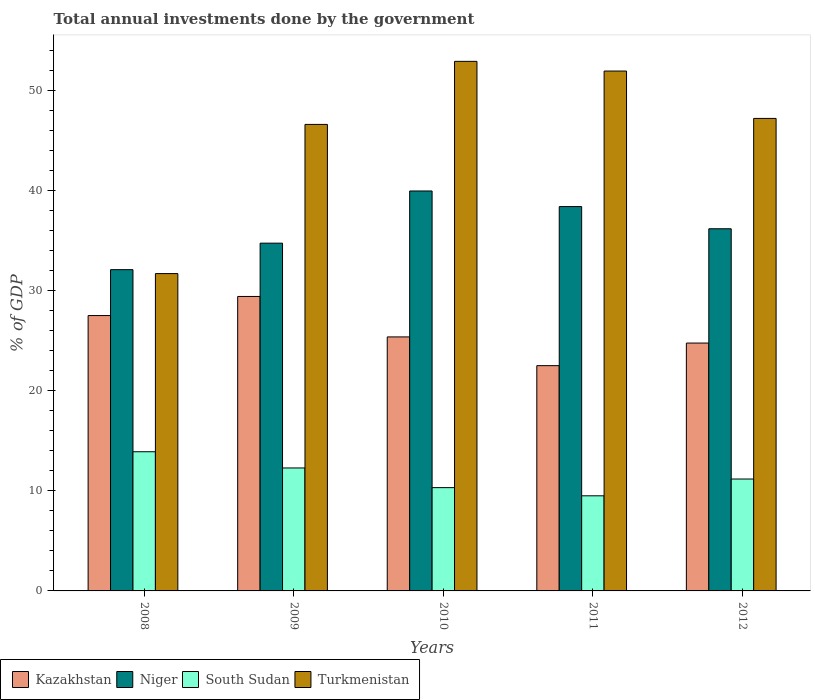How many different coloured bars are there?
Ensure brevity in your answer.  4. How many groups of bars are there?
Give a very brief answer. 5. Are the number of bars on each tick of the X-axis equal?
Offer a terse response. Yes. What is the label of the 3rd group of bars from the left?
Your answer should be compact. 2010. In how many cases, is the number of bars for a given year not equal to the number of legend labels?
Offer a terse response. 0. What is the total annual investments done by the government in Kazakhstan in 2010?
Your answer should be very brief. 25.37. Across all years, what is the maximum total annual investments done by the government in Turkmenistan?
Your answer should be compact. 52.9. Across all years, what is the minimum total annual investments done by the government in Niger?
Make the answer very short. 32.09. In which year was the total annual investments done by the government in Niger maximum?
Your answer should be very brief. 2010. What is the total total annual investments done by the government in Niger in the graph?
Your response must be concise. 181.35. What is the difference between the total annual investments done by the government in Niger in 2011 and that in 2012?
Offer a very short reply. 2.22. What is the difference between the total annual investments done by the government in South Sudan in 2008 and the total annual investments done by the government in Kazakhstan in 2009?
Keep it short and to the point. -15.51. What is the average total annual investments done by the government in Niger per year?
Your response must be concise. 36.27. In the year 2011, what is the difference between the total annual investments done by the government in Niger and total annual investments done by the government in Kazakhstan?
Your answer should be very brief. 15.89. What is the ratio of the total annual investments done by the government in Niger in 2008 to that in 2010?
Your answer should be compact. 0.8. Is the difference between the total annual investments done by the government in Niger in 2008 and 2010 greater than the difference between the total annual investments done by the government in Kazakhstan in 2008 and 2010?
Give a very brief answer. No. What is the difference between the highest and the second highest total annual investments done by the government in Turkmenistan?
Provide a succinct answer. 0.97. What is the difference between the highest and the lowest total annual investments done by the government in Turkmenistan?
Provide a short and direct response. 21.2. In how many years, is the total annual investments done by the government in Niger greater than the average total annual investments done by the government in Niger taken over all years?
Provide a succinct answer. 2. Is it the case that in every year, the sum of the total annual investments done by the government in South Sudan and total annual investments done by the government in Niger is greater than the sum of total annual investments done by the government in Kazakhstan and total annual investments done by the government in Turkmenistan?
Keep it short and to the point. No. What does the 3rd bar from the left in 2012 represents?
Your answer should be very brief. South Sudan. What does the 1st bar from the right in 2008 represents?
Your answer should be compact. Turkmenistan. Are all the bars in the graph horizontal?
Provide a short and direct response. No. How many years are there in the graph?
Keep it short and to the point. 5. Does the graph contain any zero values?
Provide a short and direct response. No. Does the graph contain grids?
Give a very brief answer. No. How many legend labels are there?
Your response must be concise. 4. How are the legend labels stacked?
Your answer should be compact. Horizontal. What is the title of the graph?
Provide a short and direct response. Total annual investments done by the government. Does "Mongolia" appear as one of the legend labels in the graph?
Your answer should be compact. No. What is the label or title of the Y-axis?
Keep it short and to the point. % of GDP. What is the % of GDP of Kazakhstan in 2008?
Offer a very short reply. 27.51. What is the % of GDP of Niger in 2008?
Your answer should be very brief. 32.09. What is the % of GDP in South Sudan in 2008?
Your answer should be very brief. 13.9. What is the % of GDP of Turkmenistan in 2008?
Provide a succinct answer. 31.7. What is the % of GDP of Kazakhstan in 2009?
Offer a terse response. 29.41. What is the % of GDP in Niger in 2009?
Your answer should be very brief. 34.74. What is the % of GDP of South Sudan in 2009?
Ensure brevity in your answer.  12.28. What is the % of GDP in Turkmenistan in 2009?
Keep it short and to the point. 46.6. What is the % of GDP of Kazakhstan in 2010?
Your answer should be compact. 25.37. What is the % of GDP of Niger in 2010?
Provide a succinct answer. 39.95. What is the % of GDP in South Sudan in 2010?
Provide a short and direct response. 10.32. What is the % of GDP of Turkmenistan in 2010?
Offer a terse response. 52.9. What is the % of GDP of Kazakhstan in 2011?
Give a very brief answer. 22.5. What is the % of GDP in Niger in 2011?
Provide a succinct answer. 38.39. What is the % of GDP of South Sudan in 2011?
Your response must be concise. 9.5. What is the % of GDP of Turkmenistan in 2011?
Provide a succinct answer. 51.93. What is the % of GDP of Kazakhstan in 2012?
Offer a terse response. 24.76. What is the % of GDP in Niger in 2012?
Your response must be concise. 36.18. What is the % of GDP of South Sudan in 2012?
Provide a short and direct response. 11.18. What is the % of GDP of Turkmenistan in 2012?
Provide a succinct answer. 47.2. Across all years, what is the maximum % of GDP in Kazakhstan?
Make the answer very short. 29.41. Across all years, what is the maximum % of GDP in Niger?
Ensure brevity in your answer.  39.95. Across all years, what is the maximum % of GDP of South Sudan?
Offer a very short reply. 13.9. Across all years, what is the maximum % of GDP of Turkmenistan?
Ensure brevity in your answer.  52.9. Across all years, what is the minimum % of GDP of Kazakhstan?
Your answer should be compact. 22.5. Across all years, what is the minimum % of GDP in Niger?
Provide a succinct answer. 32.09. Across all years, what is the minimum % of GDP in South Sudan?
Provide a short and direct response. 9.5. Across all years, what is the minimum % of GDP of Turkmenistan?
Ensure brevity in your answer.  31.7. What is the total % of GDP in Kazakhstan in the graph?
Your answer should be compact. 129.56. What is the total % of GDP in Niger in the graph?
Ensure brevity in your answer.  181.35. What is the total % of GDP in South Sudan in the graph?
Offer a very short reply. 57.18. What is the total % of GDP of Turkmenistan in the graph?
Your response must be concise. 230.33. What is the difference between the % of GDP in Kazakhstan in 2008 and that in 2009?
Keep it short and to the point. -1.91. What is the difference between the % of GDP in Niger in 2008 and that in 2009?
Keep it short and to the point. -2.65. What is the difference between the % of GDP of South Sudan in 2008 and that in 2009?
Provide a succinct answer. 1.62. What is the difference between the % of GDP in Turkmenistan in 2008 and that in 2009?
Your answer should be very brief. -14.9. What is the difference between the % of GDP in Kazakhstan in 2008 and that in 2010?
Give a very brief answer. 2.13. What is the difference between the % of GDP of Niger in 2008 and that in 2010?
Offer a terse response. -7.86. What is the difference between the % of GDP in South Sudan in 2008 and that in 2010?
Provide a succinct answer. 3.58. What is the difference between the % of GDP in Turkmenistan in 2008 and that in 2010?
Keep it short and to the point. -21.2. What is the difference between the % of GDP of Kazakhstan in 2008 and that in 2011?
Give a very brief answer. 5. What is the difference between the % of GDP of Niger in 2008 and that in 2011?
Offer a very short reply. -6.3. What is the difference between the % of GDP in South Sudan in 2008 and that in 2011?
Your response must be concise. 4.4. What is the difference between the % of GDP of Turkmenistan in 2008 and that in 2011?
Ensure brevity in your answer.  -20.23. What is the difference between the % of GDP of Kazakhstan in 2008 and that in 2012?
Your response must be concise. 2.75. What is the difference between the % of GDP of Niger in 2008 and that in 2012?
Ensure brevity in your answer.  -4.09. What is the difference between the % of GDP of South Sudan in 2008 and that in 2012?
Provide a succinct answer. 2.72. What is the difference between the % of GDP of Turkmenistan in 2008 and that in 2012?
Offer a terse response. -15.5. What is the difference between the % of GDP of Kazakhstan in 2009 and that in 2010?
Ensure brevity in your answer.  4.04. What is the difference between the % of GDP of Niger in 2009 and that in 2010?
Provide a succinct answer. -5.21. What is the difference between the % of GDP of South Sudan in 2009 and that in 2010?
Keep it short and to the point. 1.97. What is the difference between the % of GDP in Kazakhstan in 2009 and that in 2011?
Provide a succinct answer. 6.91. What is the difference between the % of GDP in Niger in 2009 and that in 2011?
Your response must be concise. -3.66. What is the difference between the % of GDP in South Sudan in 2009 and that in 2011?
Offer a very short reply. 2.78. What is the difference between the % of GDP in Turkmenistan in 2009 and that in 2011?
Your response must be concise. -5.33. What is the difference between the % of GDP of Kazakhstan in 2009 and that in 2012?
Ensure brevity in your answer.  4.65. What is the difference between the % of GDP of Niger in 2009 and that in 2012?
Provide a succinct answer. -1.44. What is the difference between the % of GDP in South Sudan in 2009 and that in 2012?
Your response must be concise. 1.1. What is the difference between the % of GDP of Turkmenistan in 2009 and that in 2012?
Your response must be concise. -0.6. What is the difference between the % of GDP in Kazakhstan in 2010 and that in 2011?
Your answer should be very brief. 2.87. What is the difference between the % of GDP in Niger in 2010 and that in 2011?
Give a very brief answer. 1.56. What is the difference between the % of GDP of South Sudan in 2010 and that in 2011?
Ensure brevity in your answer.  0.82. What is the difference between the % of GDP of Turkmenistan in 2010 and that in 2011?
Make the answer very short. 0.97. What is the difference between the % of GDP of Kazakhstan in 2010 and that in 2012?
Your response must be concise. 0.61. What is the difference between the % of GDP of Niger in 2010 and that in 2012?
Ensure brevity in your answer.  3.77. What is the difference between the % of GDP in South Sudan in 2010 and that in 2012?
Your response must be concise. -0.86. What is the difference between the % of GDP in Turkmenistan in 2010 and that in 2012?
Keep it short and to the point. 5.7. What is the difference between the % of GDP in Kazakhstan in 2011 and that in 2012?
Ensure brevity in your answer.  -2.26. What is the difference between the % of GDP of Niger in 2011 and that in 2012?
Give a very brief answer. 2.22. What is the difference between the % of GDP in South Sudan in 2011 and that in 2012?
Offer a very short reply. -1.68. What is the difference between the % of GDP of Turkmenistan in 2011 and that in 2012?
Offer a terse response. 4.73. What is the difference between the % of GDP in Kazakhstan in 2008 and the % of GDP in Niger in 2009?
Provide a short and direct response. -7.23. What is the difference between the % of GDP in Kazakhstan in 2008 and the % of GDP in South Sudan in 2009?
Offer a very short reply. 15.22. What is the difference between the % of GDP in Kazakhstan in 2008 and the % of GDP in Turkmenistan in 2009?
Your answer should be very brief. -19.09. What is the difference between the % of GDP in Niger in 2008 and the % of GDP in South Sudan in 2009?
Your response must be concise. 19.81. What is the difference between the % of GDP of Niger in 2008 and the % of GDP of Turkmenistan in 2009?
Give a very brief answer. -14.51. What is the difference between the % of GDP in South Sudan in 2008 and the % of GDP in Turkmenistan in 2009?
Your response must be concise. -32.7. What is the difference between the % of GDP in Kazakhstan in 2008 and the % of GDP in Niger in 2010?
Offer a terse response. -12.45. What is the difference between the % of GDP in Kazakhstan in 2008 and the % of GDP in South Sudan in 2010?
Provide a short and direct response. 17.19. What is the difference between the % of GDP of Kazakhstan in 2008 and the % of GDP of Turkmenistan in 2010?
Your answer should be very brief. -25.39. What is the difference between the % of GDP of Niger in 2008 and the % of GDP of South Sudan in 2010?
Provide a succinct answer. 21.77. What is the difference between the % of GDP in Niger in 2008 and the % of GDP in Turkmenistan in 2010?
Make the answer very short. -20.81. What is the difference between the % of GDP of South Sudan in 2008 and the % of GDP of Turkmenistan in 2010?
Make the answer very short. -39. What is the difference between the % of GDP in Kazakhstan in 2008 and the % of GDP in Niger in 2011?
Offer a very short reply. -10.89. What is the difference between the % of GDP of Kazakhstan in 2008 and the % of GDP of South Sudan in 2011?
Ensure brevity in your answer.  18. What is the difference between the % of GDP in Kazakhstan in 2008 and the % of GDP in Turkmenistan in 2011?
Provide a succinct answer. -24.43. What is the difference between the % of GDP in Niger in 2008 and the % of GDP in South Sudan in 2011?
Ensure brevity in your answer.  22.59. What is the difference between the % of GDP of Niger in 2008 and the % of GDP of Turkmenistan in 2011?
Provide a short and direct response. -19.84. What is the difference between the % of GDP in South Sudan in 2008 and the % of GDP in Turkmenistan in 2011?
Provide a succinct answer. -38.03. What is the difference between the % of GDP of Kazakhstan in 2008 and the % of GDP of Niger in 2012?
Your answer should be compact. -8.67. What is the difference between the % of GDP in Kazakhstan in 2008 and the % of GDP in South Sudan in 2012?
Your answer should be compact. 16.33. What is the difference between the % of GDP in Kazakhstan in 2008 and the % of GDP in Turkmenistan in 2012?
Offer a very short reply. -19.69. What is the difference between the % of GDP of Niger in 2008 and the % of GDP of South Sudan in 2012?
Your answer should be compact. 20.91. What is the difference between the % of GDP in Niger in 2008 and the % of GDP in Turkmenistan in 2012?
Offer a terse response. -15.11. What is the difference between the % of GDP in South Sudan in 2008 and the % of GDP in Turkmenistan in 2012?
Your answer should be very brief. -33.3. What is the difference between the % of GDP in Kazakhstan in 2009 and the % of GDP in Niger in 2010?
Give a very brief answer. -10.54. What is the difference between the % of GDP of Kazakhstan in 2009 and the % of GDP of South Sudan in 2010?
Make the answer very short. 19.1. What is the difference between the % of GDP in Kazakhstan in 2009 and the % of GDP in Turkmenistan in 2010?
Make the answer very short. -23.49. What is the difference between the % of GDP of Niger in 2009 and the % of GDP of South Sudan in 2010?
Keep it short and to the point. 24.42. What is the difference between the % of GDP in Niger in 2009 and the % of GDP in Turkmenistan in 2010?
Your answer should be very brief. -18.16. What is the difference between the % of GDP in South Sudan in 2009 and the % of GDP in Turkmenistan in 2010?
Give a very brief answer. -40.62. What is the difference between the % of GDP of Kazakhstan in 2009 and the % of GDP of Niger in 2011?
Provide a short and direct response. -8.98. What is the difference between the % of GDP in Kazakhstan in 2009 and the % of GDP in South Sudan in 2011?
Provide a short and direct response. 19.91. What is the difference between the % of GDP of Kazakhstan in 2009 and the % of GDP of Turkmenistan in 2011?
Ensure brevity in your answer.  -22.52. What is the difference between the % of GDP in Niger in 2009 and the % of GDP in South Sudan in 2011?
Keep it short and to the point. 25.24. What is the difference between the % of GDP in Niger in 2009 and the % of GDP in Turkmenistan in 2011?
Make the answer very short. -17.19. What is the difference between the % of GDP in South Sudan in 2009 and the % of GDP in Turkmenistan in 2011?
Provide a short and direct response. -39.65. What is the difference between the % of GDP in Kazakhstan in 2009 and the % of GDP in Niger in 2012?
Ensure brevity in your answer.  -6.76. What is the difference between the % of GDP in Kazakhstan in 2009 and the % of GDP in South Sudan in 2012?
Provide a succinct answer. 18.24. What is the difference between the % of GDP of Kazakhstan in 2009 and the % of GDP of Turkmenistan in 2012?
Keep it short and to the point. -17.79. What is the difference between the % of GDP in Niger in 2009 and the % of GDP in South Sudan in 2012?
Offer a terse response. 23.56. What is the difference between the % of GDP of Niger in 2009 and the % of GDP of Turkmenistan in 2012?
Ensure brevity in your answer.  -12.46. What is the difference between the % of GDP in South Sudan in 2009 and the % of GDP in Turkmenistan in 2012?
Give a very brief answer. -34.92. What is the difference between the % of GDP in Kazakhstan in 2010 and the % of GDP in Niger in 2011?
Provide a short and direct response. -13.02. What is the difference between the % of GDP in Kazakhstan in 2010 and the % of GDP in South Sudan in 2011?
Provide a succinct answer. 15.87. What is the difference between the % of GDP in Kazakhstan in 2010 and the % of GDP in Turkmenistan in 2011?
Provide a short and direct response. -26.56. What is the difference between the % of GDP in Niger in 2010 and the % of GDP in South Sudan in 2011?
Your response must be concise. 30.45. What is the difference between the % of GDP in Niger in 2010 and the % of GDP in Turkmenistan in 2011?
Ensure brevity in your answer.  -11.98. What is the difference between the % of GDP in South Sudan in 2010 and the % of GDP in Turkmenistan in 2011?
Provide a short and direct response. -41.61. What is the difference between the % of GDP in Kazakhstan in 2010 and the % of GDP in Niger in 2012?
Ensure brevity in your answer.  -10.8. What is the difference between the % of GDP of Kazakhstan in 2010 and the % of GDP of South Sudan in 2012?
Provide a short and direct response. 14.2. What is the difference between the % of GDP in Kazakhstan in 2010 and the % of GDP in Turkmenistan in 2012?
Your response must be concise. -21.83. What is the difference between the % of GDP in Niger in 2010 and the % of GDP in South Sudan in 2012?
Provide a short and direct response. 28.77. What is the difference between the % of GDP of Niger in 2010 and the % of GDP of Turkmenistan in 2012?
Make the answer very short. -7.25. What is the difference between the % of GDP in South Sudan in 2010 and the % of GDP in Turkmenistan in 2012?
Offer a very short reply. -36.88. What is the difference between the % of GDP of Kazakhstan in 2011 and the % of GDP of Niger in 2012?
Ensure brevity in your answer.  -13.67. What is the difference between the % of GDP in Kazakhstan in 2011 and the % of GDP in South Sudan in 2012?
Provide a short and direct response. 11.33. What is the difference between the % of GDP of Kazakhstan in 2011 and the % of GDP of Turkmenistan in 2012?
Offer a very short reply. -24.7. What is the difference between the % of GDP in Niger in 2011 and the % of GDP in South Sudan in 2012?
Make the answer very short. 27.22. What is the difference between the % of GDP of Niger in 2011 and the % of GDP of Turkmenistan in 2012?
Your answer should be very brief. -8.81. What is the difference between the % of GDP in South Sudan in 2011 and the % of GDP in Turkmenistan in 2012?
Your response must be concise. -37.7. What is the average % of GDP in Kazakhstan per year?
Your answer should be compact. 25.91. What is the average % of GDP in Niger per year?
Offer a terse response. 36.27. What is the average % of GDP in South Sudan per year?
Your response must be concise. 11.44. What is the average % of GDP of Turkmenistan per year?
Ensure brevity in your answer.  46.07. In the year 2008, what is the difference between the % of GDP of Kazakhstan and % of GDP of Niger?
Make the answer very short. -4.59. In the year 2008, what is the difference between the % of GDP in Kazakhstan and % of GDP in South Sudan?
Provide a succinct answer. 13.6. In the year 2008, what is the difference between the % of GDP of Kazakhstan and % of GDP of Turkmenistan?
Your response must be concise. -4.19. In the year 2008, what is the difference between the % of GDP of Niger and % of GDP of South Sudan?
Your answer should be very brief. 18.19. In the year 2008, what is the difference between the % of GDP of Niger and % of GDP of Turkmenistan?
Offer a terse response. 0.39. In the year 2008, what is the difference between the % of GDP in South Sudan and % of GDP in Turkmenistan?
Provide a short and direct response. -17.8. In the year 2009, what is the difference between the % of GDP in Kazakhstan and % of GDP in Niger?
Offer a terse response. -5.32. In the year 2009, what is the difference between the % of GDP of Kazakhstan and % of GDP of South Sudan?
Offer a very short reply. 17.13. In the year 2009, what is the difference between the % of GDP of Kazakhstan and % of GDP of Turkmenistan?
Your answer should be very brief. -17.19. In the year 2009, what is the difference between the % of GDP of Niger and % of GDP of South Sudan?
Offer a terse response. 22.46. In the year 2009, what is the difference between the % of GDP of Niger and % of GDP of Turkmenistan?
Provide a short and direct response. -11.86. In the year 2009, what is the difference between the % of GDP of South Sudan and % of GDP of Turkmenistan?
Offer a very short reply. -34.32. In the year 2010, what is the difference between the % of GDP of Kazakhstan and % of GDP of Niger?
Give a very brief answer. -14.58. In the year 2010, what is the difference between the % of GDP in Kazakhstan and % of GDP in South Sudan?
Ensure brevity in your answer.  15.06. In the year 2010, what is the difference between the % of GDP in Kazakhstan and % of GDP in Turkmenistan?
Provide a short and direct response. -27.53. In the year 2010, what is the difference between the % of GDP of Niger and % of GDP of South Sudan?
Provide a succinct answer. 29.63. In the year 2010, what is the difference between the % of GDP of Niger and % of GDP of Turkmenistan?
Ensure brevity in your answer.  -12.95. In the year 2010, what is the difference between the % of GDP of South Sudan and % of GDP of Turkmenistan?
Provide a short and direct response. -42.58. In the year 2011, what is the difference between the % of GDP of Kazakhstan and % of GDP of Niger?
Provide a short and direct response. -15.89. In the year 2011, what is the difference between the % of GDP of Kazakhstan and % of GDP of South Sudan?
Provide a succinct answer. 13. In the year 2011, what is the difference between the % of GDP of Kazakhstan and % of GDP of Turkmenistan?
Ensure brevity in your answer.  -29.43. In the year 2011, what is the difference between the % of GDP of Niger and % of GDP of South Sudan?
Provide a succinct answer. 28.89. In the year 2011, what is the difference between the % of GDP of Niger and % of GDP of Turkmenistan?
Your response must be concise. -13.54. In the year 2011, what is the difference between the % of GDP in South Sudan and % of GDP in Turkmenistan?
Your answer should be compact. -42.43. In the year 2012, what is the difference between the % of GDP of Kazakhstan and % of GDP of Niger?
Give a very brief answer. -11.42. In the year 2012, what is the difference between the % of GDP in Kazakhstan and % of GDP in South Sudan?
Offer a terse response. 13.58. In the year 2012, what is the difference between the % of GDP in Kazakhstan and % of GDP in Turkmenistan?
Keep it short and to the point. -22.44. In the year 2012, what is the difference between the % of GDP of Niger and % of GDP of South Sudan?
Offer a very short reply. 25. In the year 2012, what is the difference between the % of GDP of Niger and % of GDP of Turkmenistan?
Ensure brevity in your answer.  -11.02. In the year 2012, what is the difference between the % of GDP of South Sudan and % of GDP of Turkmenistan?
Your response must be concise. -36.02. What is the ratio of the % of GDP in Kazakhstan in 2008 to that in 2009?
Provide a short and direct response. 0.94. What is the ratio of the % of GDP of Niger in 2008 to that in 2009?
Keep it short and to the point. 0.92. What is the ratio of the % of GDP of South Sudan in 2008 to that in 2009?
Your answer should be compact. 1.13. What is the ratio of the % of GDP of Turkmenistan in 2008 to that in 2009?
Offer a terse response. 0.68. What is the ratio of the % of GDP in Kazakhstan in 2008 to that in 2010?
Your answer should be compact. 1.08. What is the ratio of the % of GDP in Niger in 2008 to that in 2010?
Your answer should be compact. 0.8. What is the ratio of the % of GDP in South Sudan in 2008 to that in 2010?
Make the answer very short. 1.35. What is the ratio of the % of GDP of Turkmenistan in 2008 to that in 2010?
Give a very brief answer. 0.6. What is the ratio of the % of GDP of Kazakhstan in 2008 to that in 2011?
Ensure brevity in your answer.  1.22. What is the ratio of the % of GDP in Niger in 2008 to that in 2011?
Provide a succinct answer. 0.84. What is the ratio of the % of GDP of South Sudan in 2008 to that in 2011?
Your answer should be very brief. 1.46. What is the ratio of the % of GDP of Turkmenistan in 2008 to that in 2011?
Offer a very short reply. 0.61. What is the ratio of the % of GDP of Kazakhstan in 2008 to that in 2012?
Provide a short and direct response. 1.11. What is the ratio of the % of GDP in Niger in 2008 to that in 2012?
Your answer should be very brief. 0.89. What is the ratio of the % of GDP of South Sudan in 2008 to that in 2012?
Ensure brevity in your answer.  1.24. What is the ratio of the % of GDP in Turkmenistan in 2008 to that in 2012?
Provide a succinct answer. 0.67. What is the ratio of the % of GDP of Kazakhstan in 2009 to that in 2010?
Provide a short and direct response. 1.16. What is the ratio of the % of GDP of Niger in 2009 to that in 2010?
Offer a terse response. 0.87. What is the ratio of the % of GDP in South Sudan in 2009 to that in 2010?
Your response must be concise. 1.19. What is the ratio of the % of GDP of Turkmenistan in 2009 to that in 2010?
Give a very brief answer. 0.88. What is the ratio of the % of GDP of Kazakhstan in 2009 to that in 2011?
Ensure brevity in your answer.  1.31. What is the ratio of the % of GDP in Niger in 2009 to that in 2011?
Offer a terse response. 0.9. What is the ratio of the % of GDP in South Sudan in 2009 to that in 2011?
Your response must be concise. 1.29. What is the ratio of the % of GDP of Turkmenistan in 2009 to that in 2011?
Your response must be concise. 0.9. What is the ratio of the % of GDP in Kazakhstan in 2009 to that in 2012?
Give a very brief answer. 1.19. What is the ratio of the % of GDP in Niger in 2009 to that in 2012?
Your response must be concise. 0.96. What is the ratio of the % of GDP of South Sudan in 2009 to that in 2012?
Ensure brevity in your answer.  1.1. What is the ratio of the % of GDP in Turkmenistan in 2009 to that in 2012?
Ensure brevity in your answer.  0.99. What is the ratio of the % of GDP of Kazakhstan in 2010 to that in 2011?
Make the answer very short. 1.13. What is the ratio of the % of GDP of Niger in 2010 to that in 2011?
Provide a succinct answer. 1.04. What is the ratio of the % of GDP in South Sudan in 2010 to that in 2011?
Ensure brevity in your answer.  1.09. What is the ratio of the % of GDP in Turkmenistan in 2010 to that in 2011?
Make the answer very short. 1.02. What is the ratio of the % of GDP in Kazakhstan in 2010 to that in 2012?
Your answer should be compact. 1.02. What is the ratio of the % of GDP in Niger in 2010 to that in 2012?
Give a very brief answer. 1.1. What is the ratio of the % of GDP of South Sudan in 2010 to that in 2012?
Offer a terse response. 0.92. What is the ratio of the % of GDP of Turkmenistan in 2010 to that in 2012?
Your answer should be compact. 1.12. What is the ratio of the % of GDP in Kazakhstan in 2011 to that in 2012?
Make the answer very short. 0.91. What is the ratio of the % of GDP in Niger in 2011 to that in 2012?
Offer a very short reply. 1.06. What is the ratio of the % of GDP in South Sudan in 2011 to that in 2012?
Offer a terse response. 0.85. What is the ratio of the % of GDP in Turkmenistan in 2011 to that in 2012?
Keep it short and to the point. 1.1. What is the difference between the highest and the second highest % of GDP of Kazakhstan?
Give a very brief answer. 1.91. What is the difference between the highest and the second highest % of GDP of Niger?
Your response must be concise. 1.56. What is the difference between the highest and the second highest % of GDP in South Sudan?
Provide a succinct answer. 1.62. What is the difference between the highest and the second highest % of GDP in Turkmenistan?
Ensure brevity in your answer.  0.97. What is the difference between the highest and the lowest % of GDP in Kazakhstan?
Provide a succinct answer. 6.91. What is the difference between the highest and the lowest % of GDP of Niger?
Make the answer very short. 7.86. What is the difference between the highest and the lowest % of GDP of South Sudan?
Give a very brief answer. 4.4. What is the difference between the highest and the lowest % of GDP of Turkmenistan?
Make the answer very short. 21.2. 